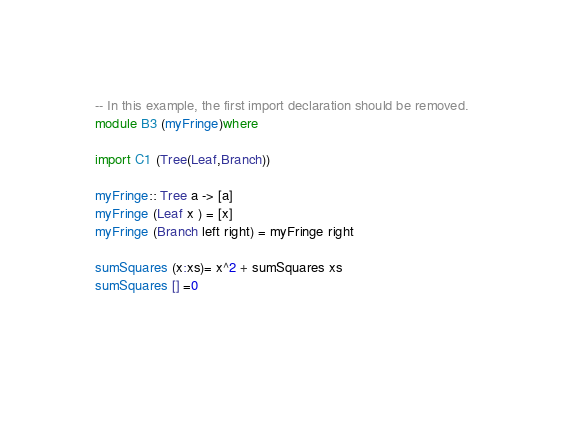<code> <loc_0><loc_0><loc_500><loc_500><_Haskell_>
-- In this example, the first import declaration should be removed.
module B3 (myFringe)where

import C1 (Tree(Leaf,Branch))

myFringe:: Tree a -> [a]
myFringe (Leaf x ) = [x]
myFringe (Branch left right) = myFringe right

sumSquares (x:xs)= x^2 + sumSquares xs
sumSquares [] =0 


  

</code> 